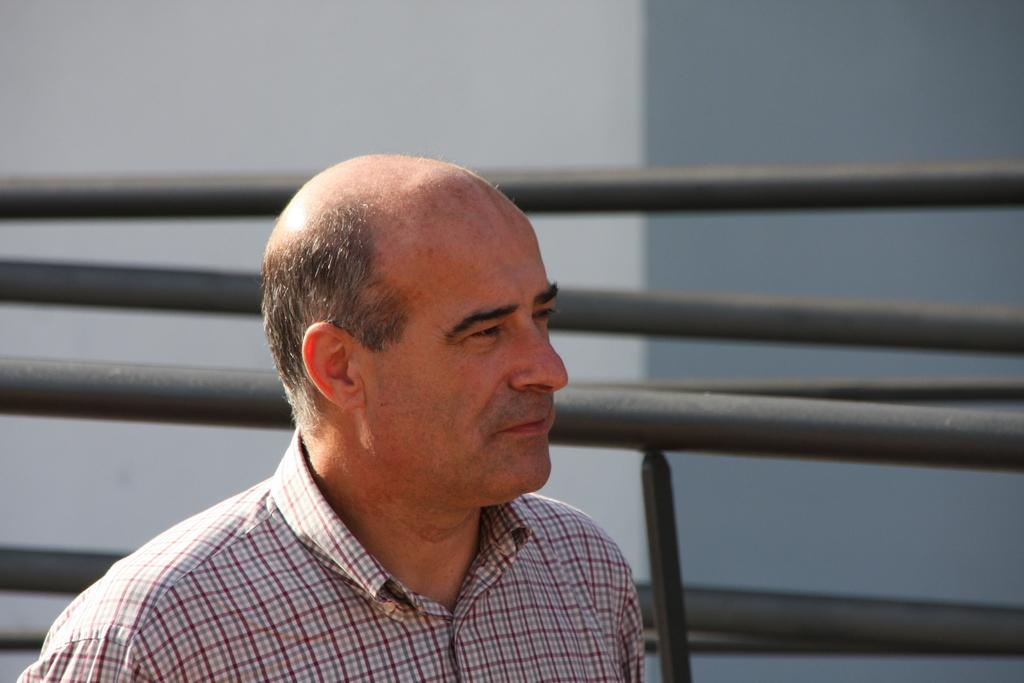Who is present in the image? There is a man in the image. What direction is the man looking in? The man is looking to the right. What is the man wearing in the image? The man is wearing a shirt. What can be seen in the background of the image? There are metal rods visible in the background of the image. What type of care does the man provide in the image? There is no indication in the image that the man is providing care or any specific service. 